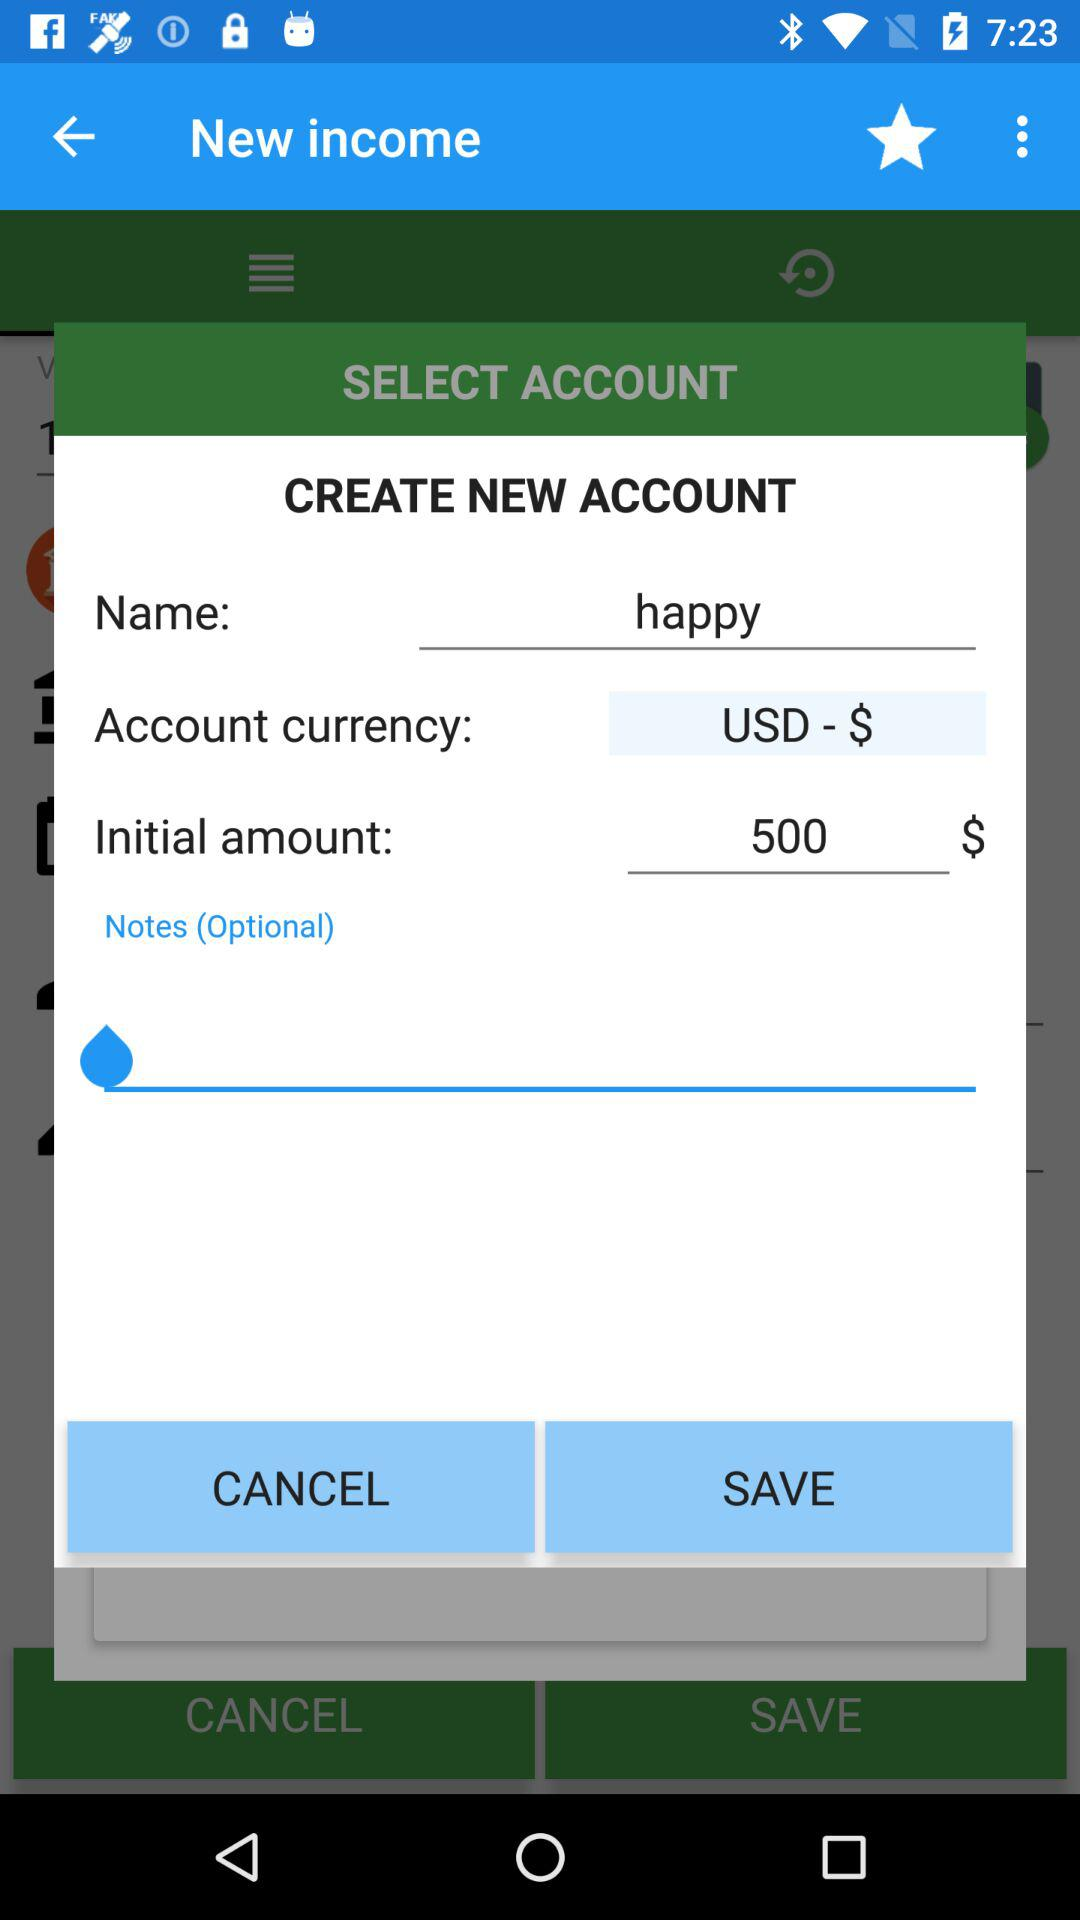What is the currency of the new account?
Answer the question using a single word or phrase. USD 